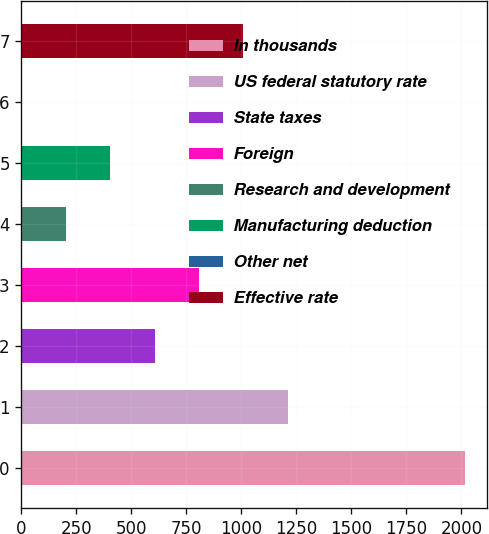Convert chart to OTSL. <chart><loc_0><loc_0><loc_500><loc_500><bar_chart><fcel>In thousands<fcel>US federal statutory rate<fcel>State taxes<fcel>Foreign<fcel>Research and development<fcel>Manufacturing deduction<fcel>Other net<fcel>Effective rate<nl><fcel>2016<fcel>1209.88<fcel>605.29<fcel>806.82<fcel>202.23<fcel>403.76<fcel>0.7<fcel>1008.35<nl></chart> 